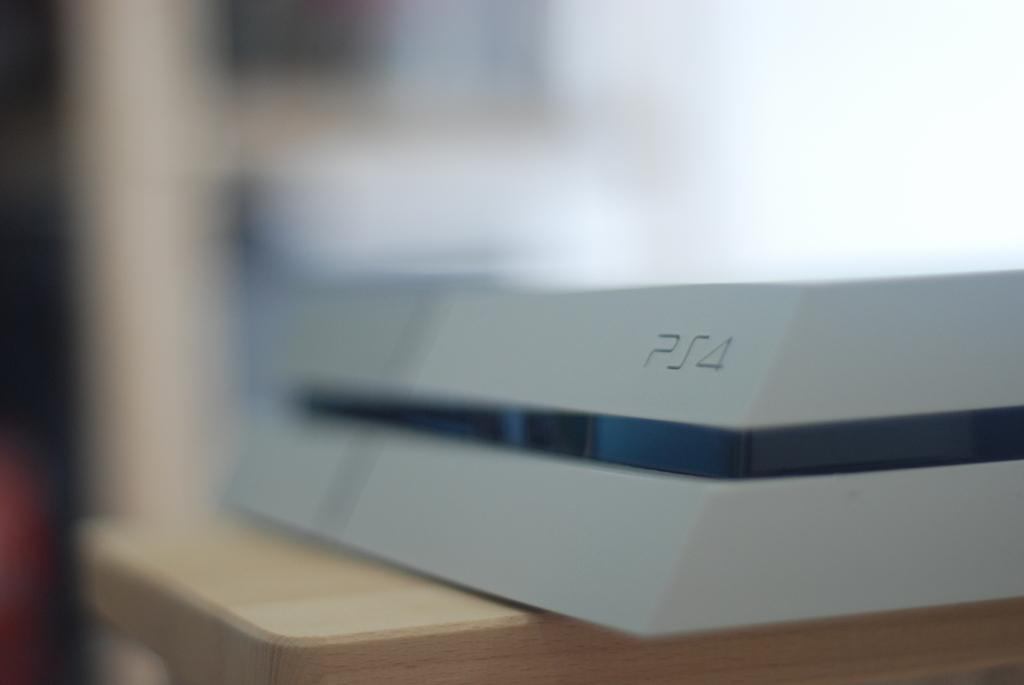What type of object is in the image? There is a wooden plank in the image. What is on the wooden plank? There is white material on the wooden plank. Can you describe the white material in more detail? There is a black line in the middle of the white material. How many passengers are waiting in the yard near the gold mine in the image? There is no reference to passengers, a yard, or a gold mine in the image; it only features a wooden plank with white material and a black line. 